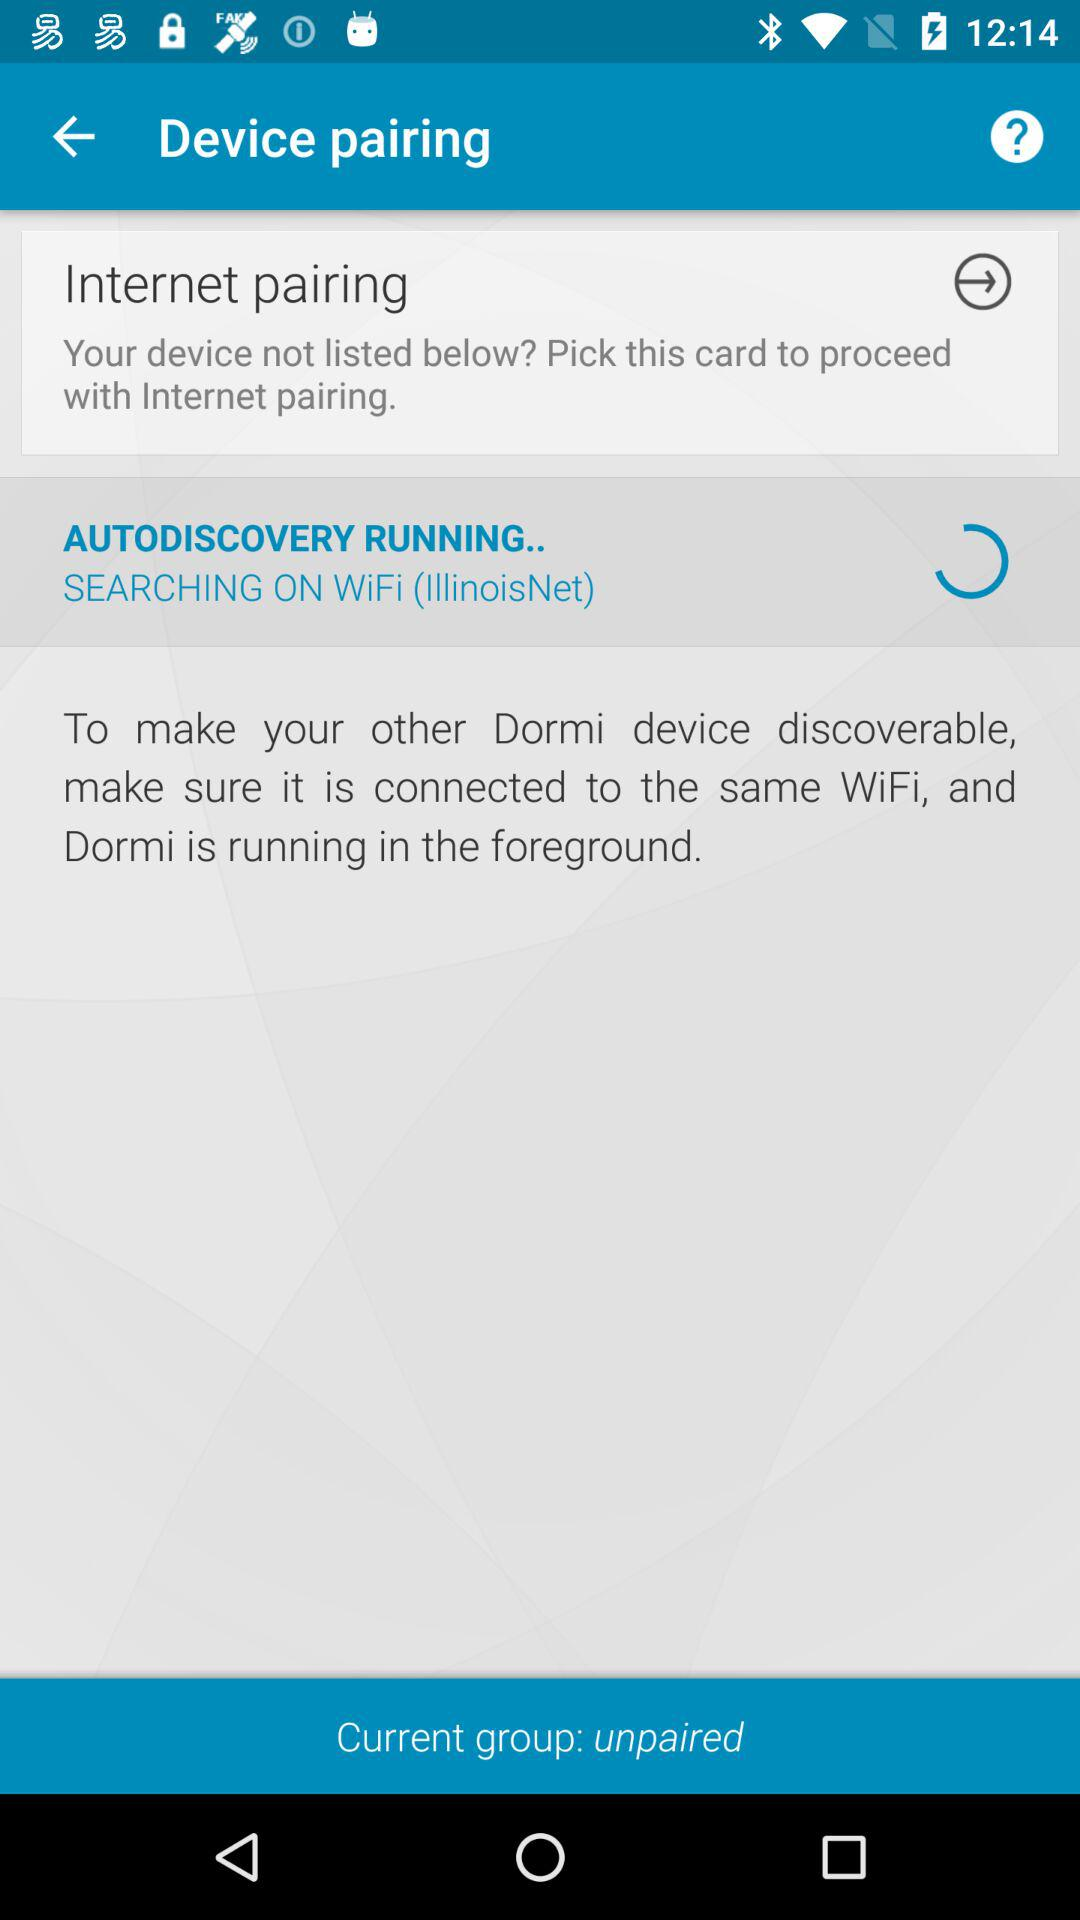What is the status of "Current group"? The status is "unpaired". 